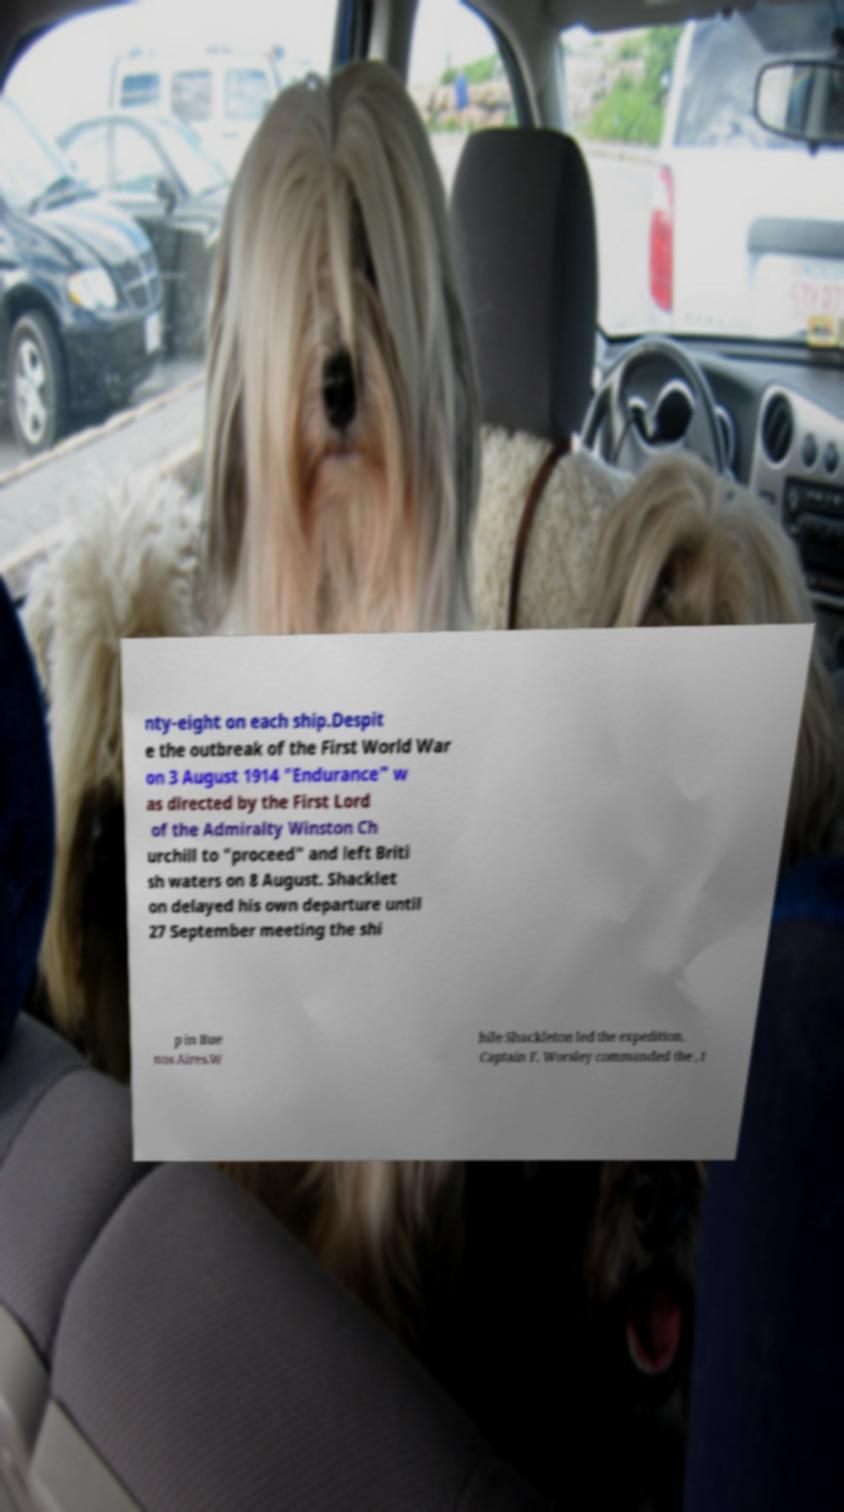Can you accurately transcribe the text from the provided image for me? nty-eight on each ship.Despit e the outbreak of the First World War on 3 August 1914 "Endurance" w as directed by the First Lord of the Admiralty Winston Ch urchill to "proceed" and left Briti sh waters on 8 August. Shacklet on delayed his own departure until 27 September meeting the shi p in Bue nos Aires.W hile Shackleton led the expedition, Captain F. Worsley commanded the , t 